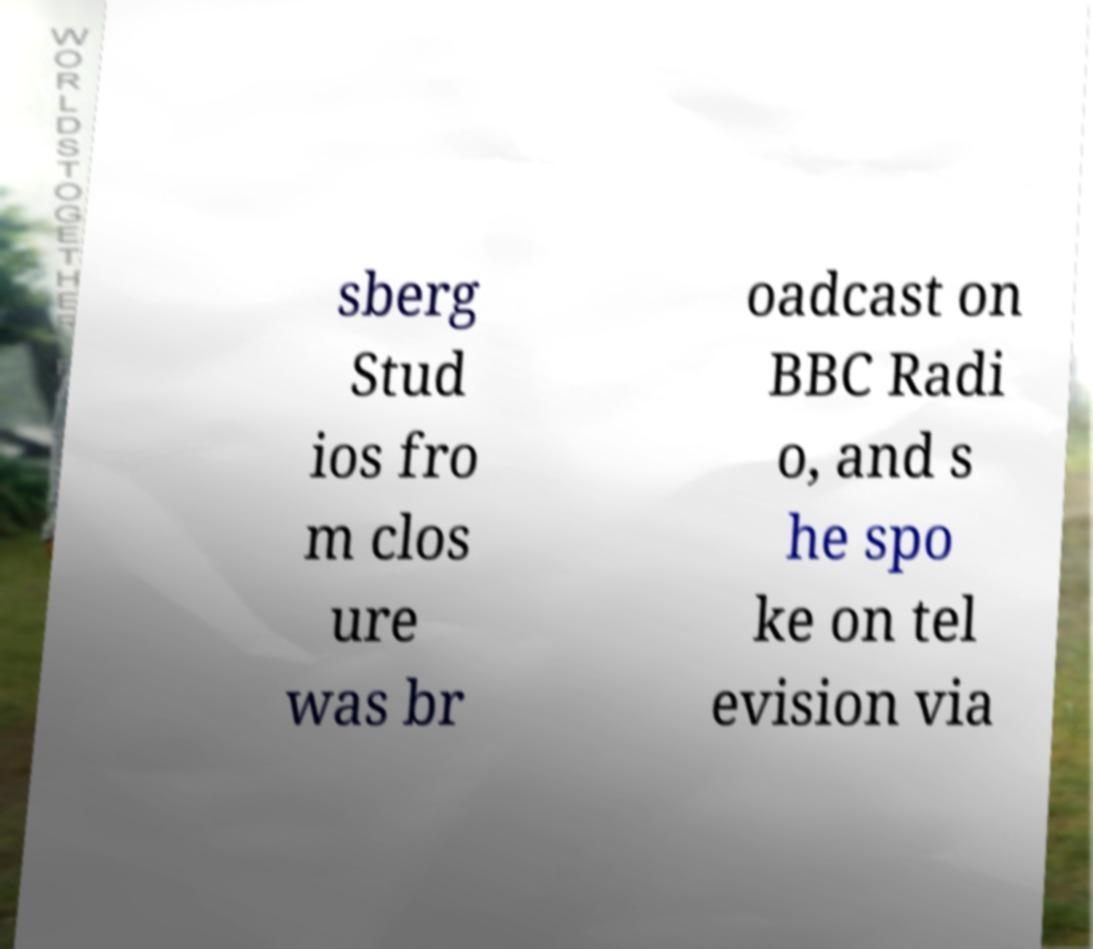Can you read and provide the text displayed in the image?This photo seems to have some interesting text. Can you extract and type it out for me? sberg Stud ios fro m clos ure was br oadcast on BBC Radi o, and s he spo ke on tel evision via 